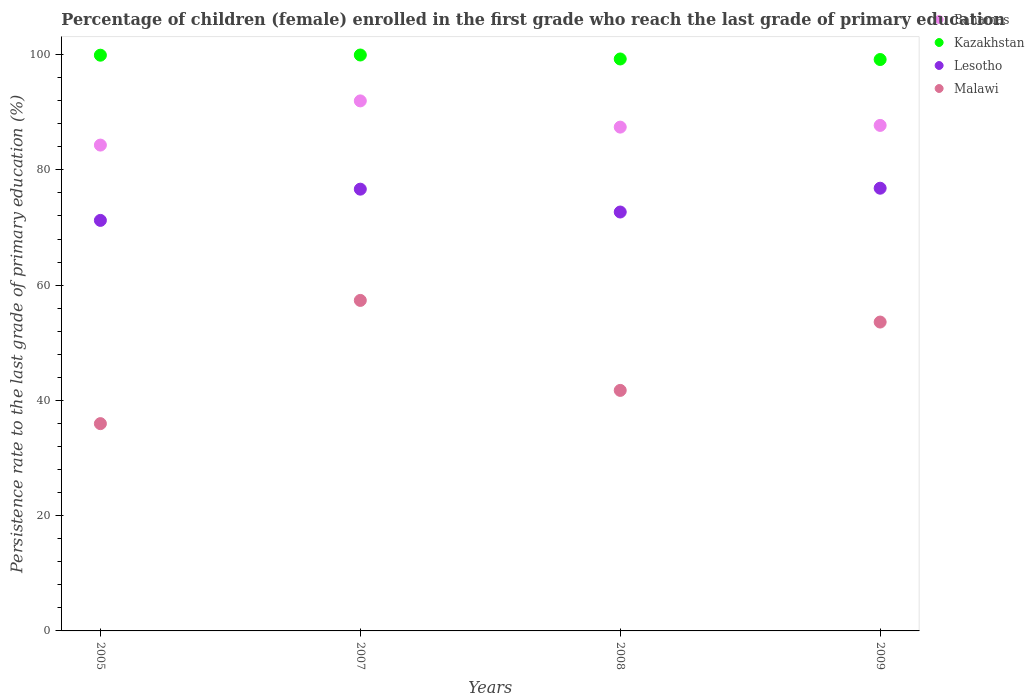What is the persistence rate of children in Kazakhstan in 2005?
Your response must be concise. 99.9. Across all years, what is the maximum persistence rate of children in Malawi?
Make the answer very short. 57.35. Across all years, what is the minimum persistence rate of children in Kazakhstan?
Ensure brevity in your answer.  99.15. In which year was the persistence rate of children in Lesotho minimum?
Your answer should be compact. 2005. What is the total persistence rate of children in Lesotho in the graph?
Your response must be concise. 297.39. What is the difference between the persistence rate of children in Lesotho in 2005 and that in 2007?
Your response must be concise. -5.42. What is the difference between the persistence rate of children in Lesotho in 2005 and the persistence rate of children in Malawi in 2009?
Keep it short and to the point. 17.64. What is the average persistence rate of children in Bahamas per year?
Your answer should be very brief. 87.85. In the year 2005, what is the difference between the persistence rate of children in Malawi and persistence rate of children in Bahamas?
Offer a very short reply. -48.33. In how many years, is the persistence rate of children in Malawi greater than 56 %?
Offer a terse response. 1. What is the ratio of the persistence rate of children in Lesotho in 2005 to that in 2008?
Offer a very short reply. 0.98. Is the persistence rate of children in Bahamas in 2005 less than that in 2009?
Your answer should be compact. Yes. What is the difference between the highest and the second highest persistence rate of children in Kazakhstan?
Keep it short and to the point. 0.03. What is the difference between the highest and the lowest persistence rate of children in Kazakhstan?
Offer a very short reply. 0.78. In how many years, is the persistence rate of children in Malawi greater than the average persistence rate of children in Malawi taken over all years?
Give a very brief answer. 2. Is the sum of the persistence rate of children in Malawi in 2005 and 2008 greater than the maximum persistence rate of children in Lesotho across all years?
Offer a terse response. Yes. Is it the case that in every year, the sum of the persistence rate of children in Lesotho and persistence rate of children in Malawi  is greater than the sum of persistence rate of children in Kazakhstan and persistence rate of children in Bahamas?
Ensure brevity in your answer.  No. Is it the case that in every year, the sum of the persistence rate of children in Malawi and persistence rate of children in Kazakhstan  is greater than the persistence rate of children in Lesotho?
Make the answer very short. Yes. Is the persistence rate of children in Bahamas strictly greater than the persistence rate of children in Kazakhstan over the years?
Your answer should be compact. No. Is the persistence rate of children in Bahamas strictly less than the persistence rate of children in Malawi over the years?
Make the answer very short. No. How many years are there in the graph?
Ensure brevity in your answer.  4. Are the values on the major ticks of Y-axis written in scientific E-notation?
Provide a short and direct response. No. Does the graph contain any zero values?
Offer a very short reply. No. What is the title of the graph?
Your answer should be very brief. Percentage of children (female) enrolled in the first grade who reach the last grade of primary education. What is the label or title of the X-axis?
Give a very brief answer. Years. What is the label or title of the Y-axis?
Provide a short and direct response. Persistence rate to the last grade of primary education (%). What is the Persistence rate to the last grade of primary education (%) of Bahamas in 2005?
Provide a short and direct response. 84.3. What is the Persistence rate to the last grade of primary education (%) of Kazakhstan in 2005?
Provide a short and direct response. 99.9. What is the Persistence rate to the last grade of primary education (%) of Lesotho in 2005?
Offer a terse response. 71.23. What is the Persistence rate to the last grade of primary education (%) of Malawi in 2005?
Your response must be concise. 35.97. What is the Persistence rate to the last grade of primary education (%) in Bahamas in 2007?
Ensure brevity in your answer.  91.97. What is the Persistence rate to the last grade of primary education (%) in Kazakhstan in 2007?
Offer a terse response. 99.93. What is the Persistence rate to the last grade of primary education (%) in Lesotho in 2007?
Offer a terse response. 76.65. What is the Persistence rate to the last grade of primary education (%) in Malawi in 2007?
Provide a succinct answer. 57.35. What is the Persistence rate to the last grade of primary education (%) in Bahamas in 2008?
Your answer should be very brief. 87.42. What is the Persistence rate to the last grade of primary education (%) of Kazakhstan in 2008?
Your answer should be very brief. 99.24. What is the Persistence rate to the last grade of primary education (%) of Lesotho in 2008?
Your answer should be compact. 72.69. What is the Persistence rate to the last grade of primary education (%) in Malawi in 2008?
Your answer should be compact. 41.74. What is the Persistence rate to the last grade of primary education (%) in Bahamas in 2009?
Your answer should be very brief. 87.72. What is the Persistence rate to the last grade of primary education (%) in Kazakhstan in 2009?
Offer a very short reply. 99.15. What is the Persistence rate to the last grade of primary education (%) of Lesotho in 2009?
Provide a short and direct response. 76.82. What is the Persistence rate to the last grade of primary education (%) of Malawi in 2009?
Provide a short and direct response. 53.59. Across all years, what is the maximum Persistence rate to the last grade of primary education (%) of Bahamas?
Provide a short and direct response. 91.97. Across all years, what is the maximum Persistence rate to the last grade of primary education (%) of Kazakhstan?
Offer a very short reply. 99.93. Across all years, what is the maximum Persistence rate to the last grade of primary education (%) of Lesotho?
Provide a short and direct response. 76.82. Across all years, what is the maximum Persistence rate to the last grade of primary education (%) in Malawi?
Provide a succinct answer. 57.35. Across all years, what is the minimum Persistence rate to the last grade of primary education (%) in Bahamas?
Your response must be concise. 84.3. Across all years, what is the minimum Persistence rate to the last grade of primary education (%) in Kazakhstan?
Ensure brevity in your answer.  99.15. Across all years, what is the minimum Persistence rate to the last grade of primary education (%) of Lesotho?
Ensure brevity in your answer.  71.23. Across all years, what is the minimum Persistence rate to the last grade of primary education (%) of Malawi?
Your answer should be very brief. 35.97. What is the total Persistence rate to the last grade of primary education (%) of Bahamas in the graph?
Ensure brevity in your answer.  351.4. What is the total Persistence rate to the last grade of primary education (%) of Kazakhstan in the graph?
Provide a short and direct response. 398.22. What is the total Persistence rate to the last grade of primary education (%) of Lesotho in the graph?
Your response must be concise. 297.39. What is the total Persistence rate to the last grade of primary education (%) in Malawi in the graph?
Your answer should be very brief. 188.65. What is the difference between the Persistence rate to the last grade of primary education (%) of Bahamas in 2005 and that in 2007?
Provide a succinct answer. -7.67. What is the difference between the Persistence rate to the last grade of primary education (%) in Kazakhstan in 2005 and that in 2007?
Your answer should be compact. -0.03. What is the difference between the Persistence rate to the last grade of primary education (%) in Lesotho in 2005 and that in 2007?
Keep it short and to the point. -5.42. What is the difference between the Persistence rate to the last grade of primary education (%) in Malawi in 2005 and that in 2007?
Give a very brief answer. -21.38. What is the difference between the Persistence rate to the last grade of primary education (%) of Bahamas in 2005 and that in 2008?
Your answer should be very brief. -3.12. What is the difference between the Persistence rate to the last grade of primary education (%) in Kazakhstan in 2005 and that in 2008?
Make the answer very short. 0.66. What is the difference between the Persistence rate to the last grade of primary education (%) in Lesotho in 2005 and that in 2008?
Your response must be concise. -1.45. What is the difference between the Persistence rate to the last grade of primary education (%) of Malawi in 2005 and that in 2008?
Keep it short and to the point. -5.77. What is the difference between the Persistence rate to the last grade of primary education (%) in Bahamas in 2005 and that in 2009?
Your answer should be very brief. -3.41. What is the difference between the Persistence rate to the last grade of primary education (%) of Kazakhstan in 2005 and that in 2009?
Ensure brevity in your answer.  0.75. What is the difference between the Persistence rate to the last grade of primary education (%) of Lesotho in 2005 and that in 2009?
Your answer should be very brief. -5.58. What is the difference between the Persistence rate to the last grade of primary education (%) in Malawi in 2005 and that in 2009?
Offer a very short reply. -17.63. What is the difference between the Persistence rate to the last grade of primary education (%) of Bahamas in 2007 and that in 2008?
Your answer should be compact. 4.55. What is the difference between the Persistence rate to the last grade of primary education (%) of Kazakhstan in 2007 and that in 2008?
Ensure brevity in your answer.  0.69. What is the difference between the Persistence rate to the last grade of primary education (%) in Lesotho in 2007 and that in 2008?
Your response must be concise. 3.97. What is the difference between the Persistence rate to the last grade of primary education (%) in Malawi in 2007 and that in 2008?
Your response must be concise. 15.61. What is the difference between the Persistence rate to the last grade of primary education (%) of Bahamas in 2007 and that in 2009?
Make the answer very short. 4.25. What is the difference between the Persistence rate to the last grade of primary education (%) in Kazakhstan in 2007 and that in 2009?
Your answer should be compact. 0.78. What is the difference between the Persistence rate to the last grade of primary education (%) of Lesotho in 2007 and that in 2009?
Offer a very short reply. -0.16. What is the difference between the Persistence rate to the last grade of primary education (%) of Malawi in 2007 and that in 2009?
Provide a succinct answer. 3.75. What is the difference between the Persistence rate to the last grade of primary education (%) of Bahamas in 2008 and that in 2009?
Provide a succinct answer. -0.3. What is the difference between the Persistence rate to the last grade of primary education (%) in Kazakhstan in 2008 and that in 2009?
Keep it short and to the point. 0.09. What is the difference between the Persistence rate to the last grade of primary education (%) in Lesotho in 2008 and that in 2009?
Offer a terse response. -4.13. What is the difference between the Persistence rate to the last grade of primary education (%) in Malawi in 2008 and that in 2009?
Your response must be concise. -11.86. What is the difference between the Persistence rate to the last grade of primary education (%) of Bahamas in 2005 and the Persistence rate to the last grade of primary education (%) of Kazakhstan in 2007?
Your answer should be compact. -15.63. What is the difference between the Persistence rate to the last grade of primary education (%) in Bahamas in 2005 and the Persistence rate to the last grade of primary education (%) in Lesotho in 2007?
Ensure brevity in your answer.  7.65. What is the difference between the Persistence rate to the last grade of primary education (%) of Bahamas in 2005 and the Persistence rate to the last grade of primary education (%) of Malawi in 2007?
Offer a terse response. 26.95. What is the difference between the Persistence rate to the last grade of primary education (%) in Kazakhstan in 2005 and the Persistence rate to the last grade of primary education (%) in Lesotho in 2007?
Make the answer very short. 23.25. What is the difference between the Persistence rate to the last grade of primary education (%) of Kazakhstan in 2005 and the Persistence rate to the last grade of primary education (%) of Malawi in 2007?
Keep it short and to the point. 42.55. What is the difference between the Persistence rate to the last grade of primary education (%) of Lesotho in 2005 and the Persistence rate to the last grade of primary education (%) of Malawi in 2007?
Provide a succinct answer. 13.88. What is the difference between the Persistence rate to the last grade of primary education (%) in Bahamas in 2005 and the Persistence rate to the last grade of primary education (%) in Kazakhstan in 2008?
Ensure brevity in your answer.  -14.94. What is the difference between the Persistence rate to the last grade of primary education (%) of Bahamas in 2005 and the Persistence rate to the last grade of primary education (%) of Lesotho in 2008?
Provide a short and direct response. 11.61. What is the difference between the Persistence rate to the last grade of primary education (%) in Bahamas in 2005 and the Persistence rate to the last grade of primary education (%) in Malawi in 2008?
Your response must be concise. 42.57. What is the difference between the Persistence rate to the last grade of primary education (%) in Kazakhstan in 2005 and the Persistence rate to the last grade of primary education (%) in Lesotho in 2008?
Your response must be concise. 27.21. What is the difference between the Persistence rate to the last grade of primary education (%) in Kazakhstan in 2005 and the Persistence rate to the last grade of primary education (%) in Malawi in 2008?
Give a very brief answer. 58.16. What is the difference between the Persistence rate to the last grade of primary education (%) in Lesotho in 2005 and the Persistence rate to the last grade of primary education (%) in Malawi in 2008?
Your answer should be very brief. 29.5. What is the difference between the Persistence rate to the last grade of primary education (%) of Bahamas in 2005 and the Persistence rate to the last grade of primary education (%) of Kazakhstan in 2009?
Offer a terse response. -14.85. What is the difference between the Persistence rate to the last grade of primary education (%) of Bahamas in 2005 and the Persistence rate to the last grade of primary education (%) of Lesotho in 2009?
Keep it short and to the point. 7.48. What is the difference between the Persistence rate to the last grade of primary education (%) of Bahamas in 2005 and the Persistence rate to the last grade of primary education (%) of Malawi in 2009?
Your response must be concise. 30.71. What is the difference between the Persistence rate to the last grade of primary education (%) in Kazakhstan in 2005 and the Persistence rate to the last grade of primary education (%) in Lesotho in 2009?
Provide a short and direct response. 23.08. What is the difference between the Persistence rate to the last grade of primary education (%) in Kazakhstan in 2005 and the Persistence rate to the last grade of primary education (%) in Malawi in 2009?
Make the answer very short. 46.3. What is the difference between the Persistence rate to the last grade of primary education (%) in Lesotho in 2005 and the Persistence rate to the last grade of primary education (%) in Malawi in 2009?
Ensure brevity in your answer.  17.64. What is the difference between the Persistence rate to the last grade of primary education (%) of Bahamas in 2007 and the Persistence rate to the last grade of primary education (%) of Kazakhstan in 2008?
Your answer should be very brief. -7.27. What is the difference between the Persistence rate to the last grade of primary education (%) of Bahamas in 2007 and the Persistence rate to the last grade of primary education (%) of Lesotho in 2008?
Keep it short and to the point. 19.28. What is the difference between the Persistence rate to the last grade of primary education (%) of Bahamas in 2007 and the Persistence rate to the last grade of primary education (%) of Malawi in 2008?
Make the answer very short. 50.23. What is the difference between the Persistence rate to the last grade of primary education (%) of Kazakhstan in 2007 and the Persistence rate to the last grade of primary education (%) of Lesotho in 2008?
Your response must be concise. 27.24. What is the difference between the Persistence rate to the last grade of primary education (%) in Kazakhstan in 2007 and the Persistence rate to the last grade of primary education (%) in Malawi in 2008?
Your response must be concise. 58.2. What is the difference between the Persistence rate to the last grade of primary education (%) in Lesotho in 2007 and the Persistence rate to the last grade of primary education (%) in Malawi in 2008?
Keep it short and to the point. 34.92. What is the difference between the Persistence rate to the last grade of primary education (%) of Bahamas in 2007 and the Persistence rate to the last grade of primary education (%) of Kazakhstan in 2009?
Ensure brevity in your answer.  -7.18. What is the difference between the Persistence rate to the last grade of primary education (%) of Bahamas in 2007 and the Persistence rate to the last grade of primary education (%) of Lesotho in 2009?
Keep it short and to the point. 15.15. What is the difference between the Persistence rate to the last grade of primary education (%) of Bahamas in 2007 and the Persistence rate to the last grade of primary education (%) of Malawi in 2009?
Make the answer very short. 38.37. What is the difference between the Persistence rate to the last grade of primary education (%) of Kazakhstan in 2007 and the Persistence rate to the last grade of primary education (%) of Lesotho in 2009?
Provide a short and direct response. 23.11. What is the difference between the Persistence rate to the last grade of primary education (%) of Kazakhstan in 2007 and the Persistence rate to the last grade of primary education (%) of Malawi in 2009?
Provide a succinct answer. 46.34. What is the difference between the Persistence rate to the last grade of primary education (%) in Lesotho in 2007 and the Persistence rate to the last grade of primary education (%) in Malawi in 2009?
Offer a terse response. 23.06. What is the difference between the Persistence rate to the last grade of primary education (%) of Bahamas in 2008 and the Persistence rate to the last grade of primary education (%) of Kazakhstan in 2009?
Your answer should be compact. -11.73. What is the difference between the Persistence rate to the last grade of primary education (%) in Bahamas in 2008 and the Persistence rate to the last grade of primary education (%) in Lesotho in 2009?
Give a very brief answer. 10.6. What is the difference between the Persistence rate to the last grade of primary education (%) of Bahamas in 2008 and the Persistence rate to the last grade of primary education (%) of Malawi in 2009?
Offer a terse response. 33.82. What is the difference between the Persistence rate to the last grade of primary education (%) of Kazakhstan in 2008 and the Persistence rate to the last grade of primary education (%) of Lesotho in 2009?
Give a very brief answer. 22.43. What is the difference between the Persistence rate to the last grade of primary education (%) of Kazakhstan in 2008 and the Persistence rate to the last grade of primary education (%) of Malawi in 2009?
Your response must be concise. 45.65. What is the difference between the Persistence rate to the last grade of primary education (%) in Lesotho in 2008 and the Persistence rate to the last grade of primary education (%) in Malawi in 2009?
Your answer should be compact. 19.09. What is the average Persistence rate to the last grade of primary education (%) in Bahamas per year?
Your response must be concise. 87.85. What is the average Persistence rate to the last grade of primary education (%) in Kazakhstan per year?
Offer a very short reply. 99.56. What is the average Persistence rate to the last grade of primary education (%) in Lesotho per year?
Give a very brief answer. 74.35. What is the average Persistence rate to the last grade of primary education (%) of Malawi per year?
Provide a succinct answer. 47.16. In the year 2005, what is the difference between the Persistence rate to the last grade of primary education (%) of Bahamas and Persistence rate to the last grade of primary education (%) of Kazakhstan?
Offer a very short reply. -15.6. In the year 2005, what is the difference between the Persistence rate to the last grade of primary education (%) in Bahamas and Persistence rate to the last grade of primary education (%) in Lesotho?
Your answer should be compact. 13.07. In the year 2005, what is the difference between the Persistence rate to the last grade of primary education (%) of Bahamas and Persistence rate to the last grade of primary education (%) of Malawi?
Your answer should be very brief. 48.33. In the year 2005, what is the difference between the Persistence rate to the last grade of primary education (%) in Kazakhstan and Persistence rate to the last grade of primary education (%) in Lesotho?
Give a very brief answer. 28.66. In the year 2005, what is the difference between the Persistence rate to the last grade of primary education (%) in Kazakhstan and Persistence rate to the last grade of primary education (%) in Malawi?
Offer a very short reply. 63.93. In the year 2005, what is the difference between the Persistence rate to the last grade of primary education (%) of Lesotho and Persistence rate to the last grade of primary education (%) of Malawi?
Give a very brief answer. 35.27. In the year 2007, what is the difference between the Persistence rate to the last grade of primary education (%) in Bahamas and Persistence rate to the last grade of primary education (%) in Kazakhstan?
Provide a succinct answer. -7.96. In the year 2007, what is the difference between the Persistence rate to the last grade of primary education (%) in Bahamas and Persistence rate to the last grade of primary education (%) in Lesotho?
Offer a very short reply. 15.31. In the year 2007, what is the difference between the Persistence rate to the last grade of primary education (%) of Bahamas and Persistence rate to the last grade of primary education (%) of Malawi?
Your answer should be very brief. 34.62. In the year 2007, what is the difference between the Persistence rate to the last grade of primary education (%) in Kazakhstan and Persistence rate to the last grade of primary education (%) in Lesotho?
Offer a terse response. 23.28. In the year 2007, what is the difference between the Persistence rate to the last grade of primary education (%) of Kazakhstan and Persistence rate to the last grade of primary education (%) of Malawi?
Ensure brevity in your answer.  42.58. In the year 2007, what is the difference between the Persistence rate to the last grade of primary education (%) of Lesotho and Persistence rate to the last grade of primary education (%) of Malawi?
Your answer should be very brief. 19.3. In the year 2008, what is the difference between the Persistence rate to the last grade of primary education (%) of Bahamas and Persistence rate to the last grade of primary education (%) of Kazakhstan?
Make the answer very short. -11.82. In the year 2008, what is the difference between the Persistence rate to the last grade of primary education (%) of Bahamas and Persistence rate to the last grade of primary education (%) of Lesotho?
Your answer should be very brief. 14.73. In the year 2008, what is the difference between the Persistence rate to the last grade of primary education (%) of Bahamas and Persistence rate to the last grade of primary education (%) of Malawi?
Offer a very short reply. 45.68. In the year 2008, what is the difference between the Persistence rate to the last grade of primary education (%) in Kazakhstan and Persistence rate to the last grade of primary education (%) in Lesotho?
Provide a succinct answer. 26.55. In the year 2008, what is the difference between the Persistence rate to the last grade of primary education (%) in Kazakhstan and Persistence rate to the last grade of primary education (%) in Malawi?
Your answer should be very brief. 57.51. In the year 2008, what is the difference between the Persistence rate to the last grade of primary education (%) in Lesotho and Persistence rate to the last grade of primary education (%) in Malawi?
Keep it short and to the point. 30.95. In the year 2009, what is the difference between the Persistence rate to the last grade of primary education (%) of Bahamas and Persistence rate to the last grade of primary education (%) of Kazakhstan?
Your answer should be very brief. -11.43. In the year 2009, what is the difference between the Persistence rate to the last grade of primary education (%) in Bahamas and Persistence rate to the last grade of primary education (%) in Lesotho?
Your response must be concise. 10.9. In the year 2009, what is the difference between the Persistence rate to the last grade of primary education (%) of Bahamas and Persistence rate to the last grade of primary education (%) of Malawi?
Make the answer very short. 34.12. In the year 2009, what is the difference between the Persistence rate to the last grade of primary education (%) in Kazakhstan and Persistence rate to the last grade of primary education (%) in Lesotho?
Provide a succinct answer. 22.33. In the year 2009, what is the difference between the Persistence rate to the last grade of primary education (%) of Kazakhstan and Persistence rate to the last grade of primary education (%) of Malawi?
Your answer should be compact. 45.55. In the year 2009, what is the difference between the Persistence rate to the last grade of primary education (%) in Lesotho and Persistence rate to the last grade of primary education (%) in Malawi?
Keep it short and to the point. 23.22. What is the ratio of the Persistence rate to the last grade of primary education (%) in Bahamas in 2005 to that in 2007?
Your answer should be very brief. 0.92. What is the ratio of the Persistence rate to the last grade of primary education (%) of Lesotho in 2005 to that in 2007?
Your response must be concise. 0.93. What is the ratio of the Persistence rate to the last grade of primary education (%) in Malawi in 2005 to that in 2007?
Provide a succinct answer. 0.63. What is the ratio of the Persistence rate to the last grade of primary education (%) of Kazakhstan in 2005 to that in 2008?
Provide a short and direct response. 1.01. What is the ratio of the Persistence rate to the last grade of primary education (%) in Lesotho in 2005 to that in 2008?
Offer a very short reply. 0.98. What is the ratio of the Persistence rate to the last grade of primary education (%) of Malawi in 2005 to that in 2008?
Ensure brevity in your answer.  0.86. What is the ratio of the Persistence rate to the last grade of primary education (%) in Bahamas in 2005 to that in 2009?
Offer a very short reply. 0.96. What is the ratio of the Persistence rate to the last grade of primary education (%) in Kazakhstan in 2005 to that in 2009?
Ensure brevity in your answer.  1.01. What is the ratio of the Persistence rate to the last grade of primary education (%) of Lesotho in 2005 to that in 2009?
Make the answer very short. 0.93. What is the ratio of the Persistence rate to the last grade of primary education (%) of Malawi in 2005 to that in 2009?
Provide a short and direct response. 0.67. What is the ratio of the Persistence rate to the last grade of primary education (%) of Bahamas in 2007 to that in 2008?
Give a very brief answer. 1.05. What is the ratio of the Persistence rate to the last grade of primary education (%) of Lesotho in 2007 to that in 2008?
Offer a terse response. 1.05. What is the ratio of the Persistence rate to the last grade of primary education (%) of Malawi in 2007 to that in 2008?
Ensure brevity in your answer.  1.37. What is the ratio of the Persistence rate to the last grade of primary education (%) in Bahamas in 2007 to that in 2009?
Keep it short and to the point. 1.05. What is the ratio of the Persistence rate to the last grade of primary education (%) of Kazakhstan in 2007 to that in 2009?
Ensure brevity in your answer.  1.01. What is the ratio of the Persistence rate to the last grade of primary education (%) in Malawi in 2007 to that in 2009?
Your answer should be very brief. 1.07. What is the ratio of the Persistence rate to the last grade of primary education (%) in Kazakhstan in 2008 to that in 2009?
Ensure brevity in your answer.  1. What is the ratio of the Persistence rate to the last grade of primary education (%) in Lesotho in 2008 to that in 2009?
Ensure brevity in your answer.  0.95. What is the ratio of the Persistence rate to the last grade of primary education (%) in Malawi in 2008 to that in 2009?
Your answer should be compact. 0.78. What is the difference between the highest and the second highest Persistence rate to the last grade of primary education (%) in Bahamas?
Your response must be concise. 4.25. What is the difference between the highest and the second highest Persistence rate to the last grade of primary education (%) of Kazakhstan?
Your response must be concise. 0.03. What is the difference between the highest and the second highest Persistence rate to the last grade of primary education (%) in Lesotho?
Keep it short and to the point. 0.16. What is the difference between the highest and the second highest Persistence rate to the last grade of primary education (%) of Malawi?
Provide a succinct answer. 3.75. What is the difference between the highest and the lowest Persistence rate to the last grade of primary education (%) in Bahamas?
Provide a short and direct response. 7.67. What is the difference between the highest and the lowest Persistence rate to the last grade of primary education (%) of Kazakhstan?
Ensure brevity in your answer.  0.78. What is the difference between the highest and the lowest Persistence rate to the last grade of primary education (%) in Lesotho?
Ensure brevity in your answer.  5.58. What is the difference between the highest and the lowest Persistence rate to the last grade of primary education (%) of Malawi?
Your answer should be compact. 21.38. 